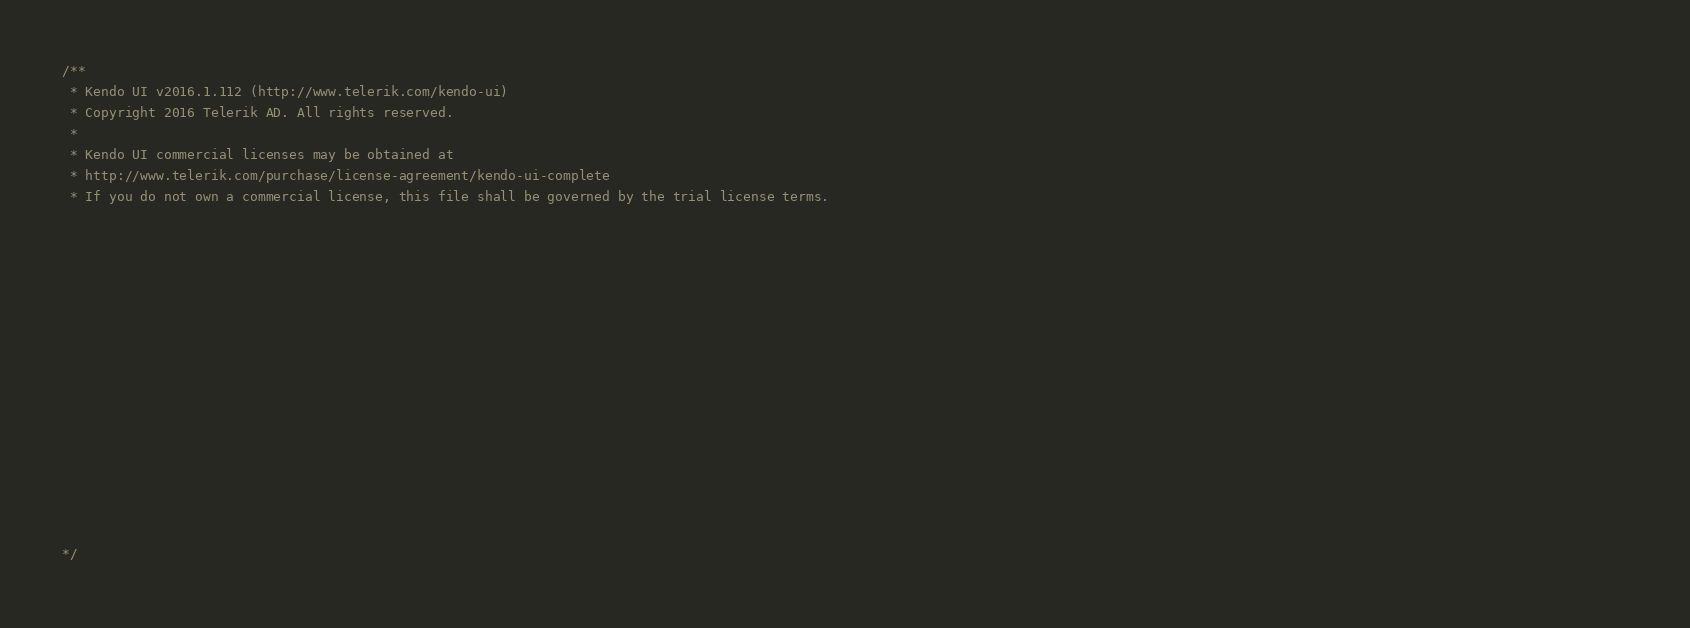<code> <loc_0><loc_0><loc_500><loc_500><_JavaScript_>/** 
 * Kendo UI v2016.1.112 (http://www.telerik.com/kendo-ui)                                                                                                                                               
 * Copyright 2016 Telerik AD. All rights reserved.                                                                                                                                                      
 *                                                                                                                                                                                                      
 * Kendo UI commercial licenses may be obtained at                                                                                                                                                      
 * http://www.telerik.com/purchase/license-agreement/kendo-ui-complete                                                                                                                                  
 * If you do not own a commercial license, this file shall be governed by the trial license terms.                                                                                                      
                                                                                                                                                                                                       
                                                                                                                                                                                                       
                                                                                                                                                                                                       
                                                                                                                                                                                                       
                                                                                                                                                                                                       
                                                                                                                                                                                                       
                                                                                                                                                                                                       
                                                                                                                                                                                                       
                                                                                                                                                                                                       
                                                                                                                                                                                                       
                                                                                                                                                                                                       
                                                                                                                                                                                                       
                                                                                                                                                                                                       
                                                                                                                                                                                                       
                                                                                                                                                                                                       

*/</code> 